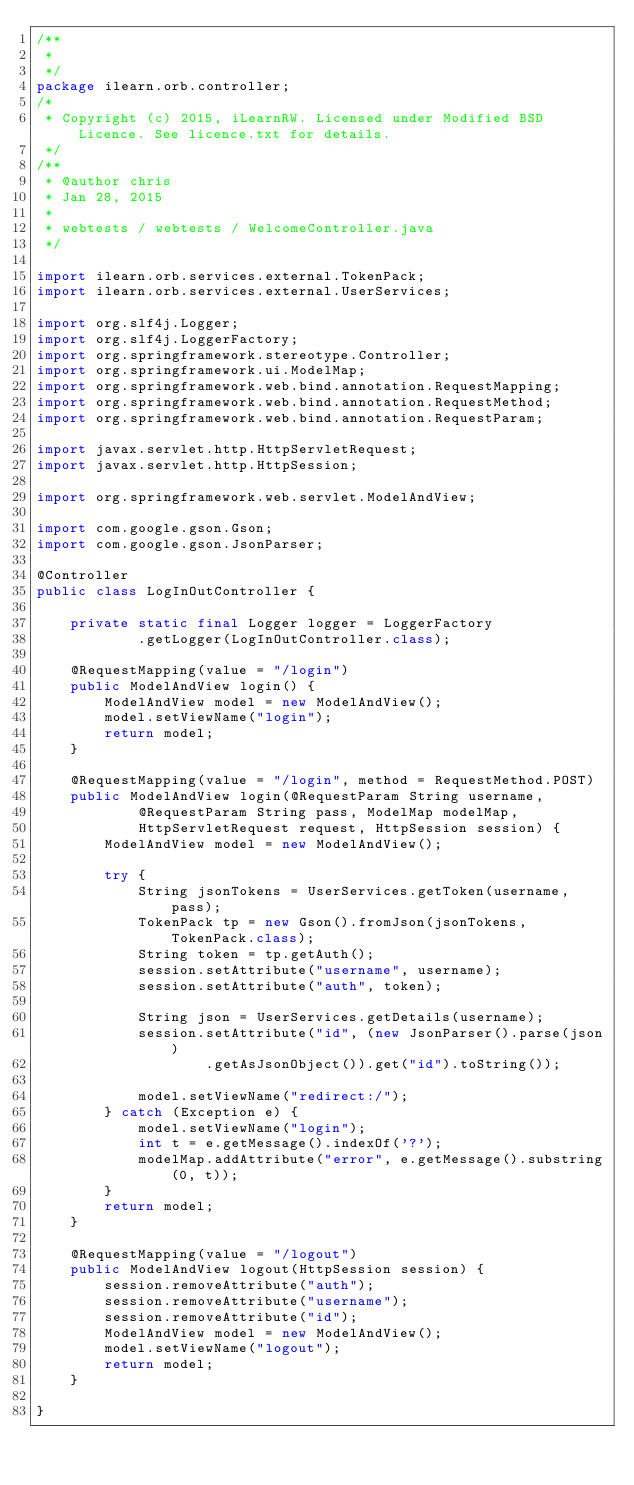Convert code to text. <code><loc_0><loc_0><loc_500><loc_500><_Java_>/**
 * 
 */
package ilearn.orb.controller;
/*
 * Copyright (c) 2015, iLearnRW. Licensed under Modified BSD Licence. See licence.txt for details.
 */
/**
 * @author chris
 * Jan 28, 2015
 *
 * webtests / webtests / WelcomeController.java
 */

import ilearn.orb.services.external.TokenPack;
import ilearn.orb.services.external.UserServices;

import org.slf4j.Logger;
import org.slf4j.LoggerFactory;
import org.springframework.stereotype.Controller;
import org.springframework.ui.ModelMap;
import org.springframework.web.bind.annotation.RequestMapping;
import org.springframework.web.bind.annotation.RequestMethod;
import org.springframework.web.bind.annotation.RequestParam;

import javax.servlet.http.HttpServletRequest;
import javax.servlet.http.HttpSession;

import org.springframework.web.servlet.ModelAndView;

import com.google.gson.Gson;
import com.google.gson.JsonParser;

@Controller
public class LogInOutController {

	private static final Logger logger = LoggerFactory
			.getLogger(LogInOutController.class);

	@RequestMapping(value = "/login")
	public ModelAndView login() {
		ModelAndView model = new ModelAndView();
		model.setViewName("login");
		return model;
	}

	@RequestMapping(value = "/login", method = RequestMethod.POST)
	public ModelAndView login(@RequestParam String username,
			@RequestParam String pass, ModelMap modelMap,
			HttpServletRequest request, HttpSession session) {
		ModelAndView model = new ModelAndView();

		try {
			String jsonTokens = UserServices.getToken(username, pass);
			TokenPack tp = new Gson().fromJson(jsonTokens, TokenPack.class);
			String token = tp.getAuth();
			session.setAttribute("username", username);
			session.setAttribute("auth", token);

			String json = UserServices.getDetails(username);
			session.setAttribute("id", (new JsonParser().parse(json)
					.getAsJsonObject()).get("id").toString());

			model.setViewName("redirect:/");
		} catch (Exception e) {
			model.setViewName("login");
			int t = e.getMessage().indexOf('?');
			modelMap.addAttribute("error", e.getMessage().substring(0, t));
		}
		return model;
	}

	@RequestMapping(value = "/logout")
	public ModelAndView logout(HttpSession session) {
		session.removeAttribute("auth");
		session.removeAttribute("username");
		session.removeAttribute("id");
		ModelAndView model = new ModelAndView();
		model.setViewName("logout");
		return model;
	}

}</code> 